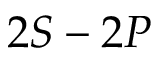<formula> <loc_0><loc_0><loc_500><loc_500>2 S - 2 P</formula> 